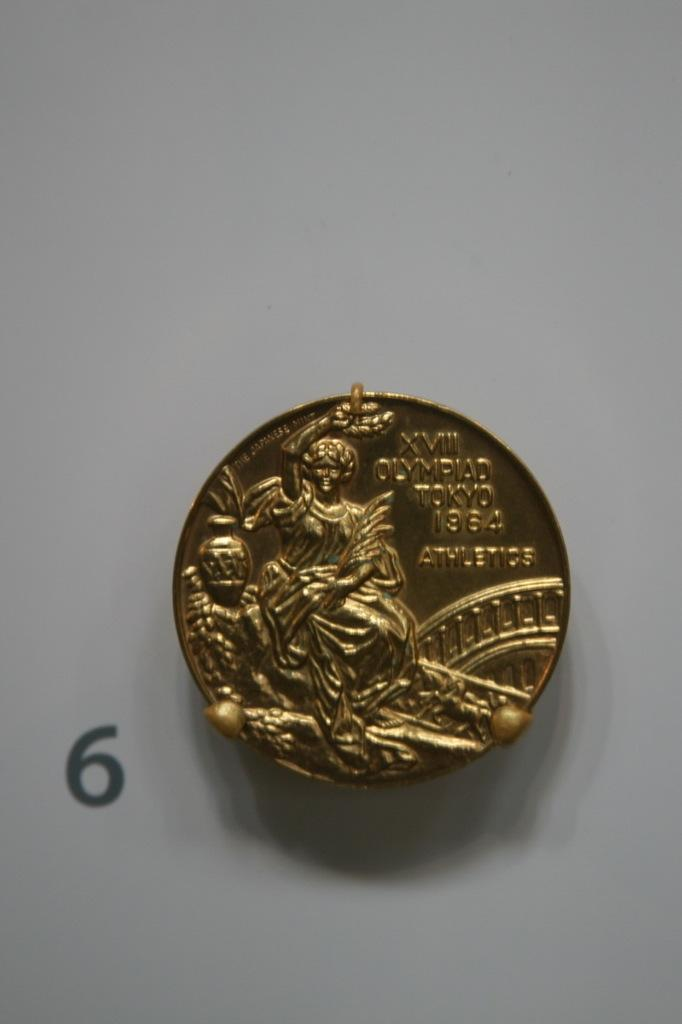<image>
Write a terse but informative summary of the picture. A gold peice of change with XVIII OLYMPIAD TOKYO 1964 ATHLETICS. 